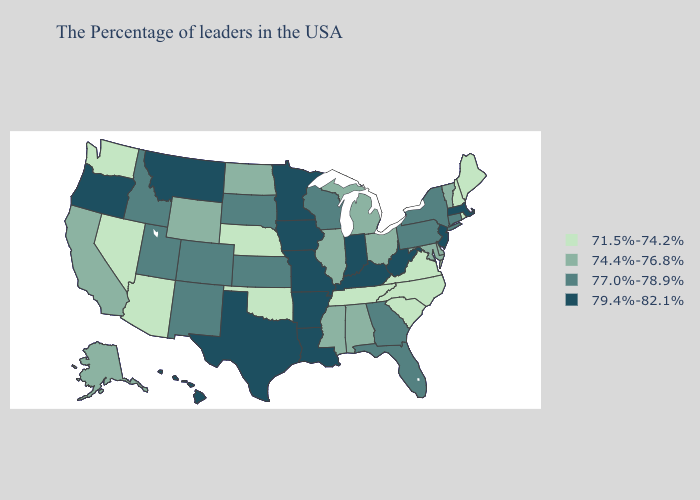Is the legend a continuous bar?
Keep it brief. No. Which states hav the highest value in the South?
Keep it brief. West Virginia, Kentucky, Louisiana, Arkansas, Texas. What is the highest value in the South ?
Concise answer only. 79.4%-82.1%. Does New Mexico have the lowest value in the USA?
Answer briefly. No. What is the value of Missouri?
Concise answer only. 79.4%-82.1%. Name the states that have a value in the range 77.0%-78.9%?
Write a very short answer. Connecticut, New York, Pennsylvania, Florida, Georgia, Wisconsin, Kansas, South Dakota, Colorado, New Mexico, Utah, Idaho. Does Delaware have a higher value than Arkansas?
Be succinct. No. Name the states that have a value in the range 77.0%-78.9%?
Be succinct. Connecticut, New York, Pennsylvania, Florida, Georgia, Wisconsin, Kansas, South Dakota, Colorado, New Mexico, Utah, Idaho. Does the map have missing data?
Answer briefly. No. Name the states that have a value in the range 74.4%-76.8%?
Write a very short answer. Vermont, Delaware, Maryland, Ohio, Michigan, Alabama, Illinois, Mississippi, North Dakota, Wyoming, California, Alaska. Among the states that border California , does Oregon have the highest value?
Concise answer only. Yes. What is the value of Florida?
Concise answer only. 77.0%-78.9%. What is the value of Colorado?
Write a very short answer. 77.0%-78.9%. What is the value of Maryland?
Keep it brief. 74.4%-76.8%. Among the states that border Louisiana , which have the highest value?
Concise answer only. Arkansas, Texas. 